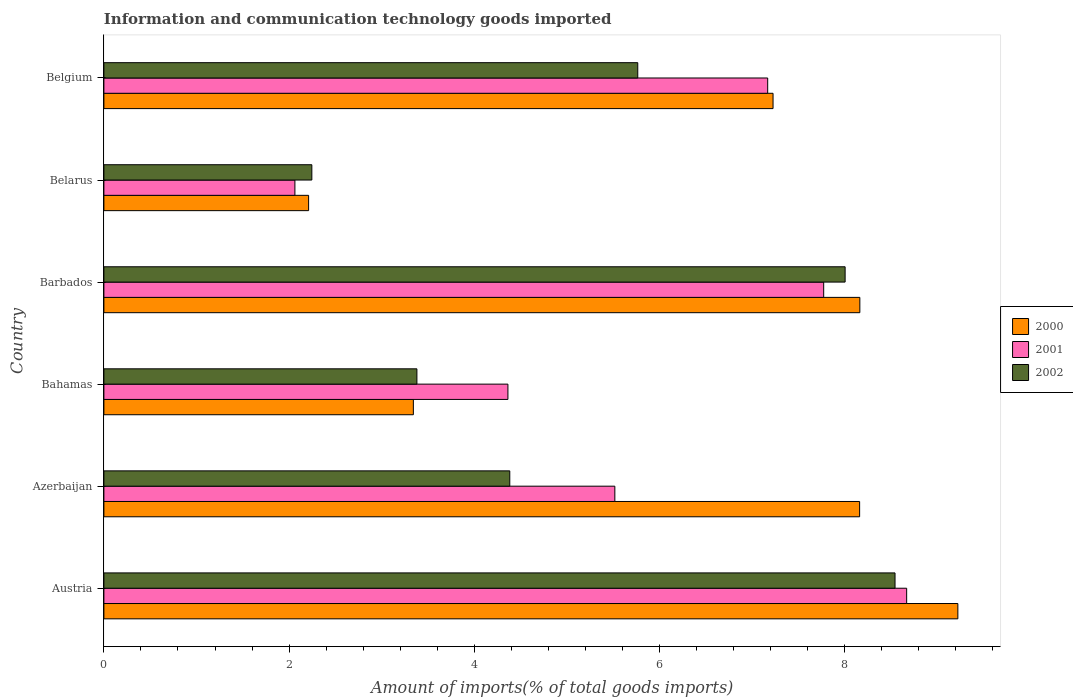How many different coloured bars are there?
Your answer should be compact. 3. How many groups of bars are there?
Your response must be concise. 6. Are the number of bars on each tick of the Y-axis equal?
Make the answer very short. Yes. How many bars are there on the 1st tick from the bottom?
Your answer should be compact. 3. What is the label of the 2nd group of bars from the top?
Your answer should be very brief. Belarus. In how many cases, is the number of bars for a given country not equal to the number of legend labels?
Offer a terse response. 0. What is the amount of goods imported in 2001 in Belarus?
Your response must be concise. 2.06. Across all countries, what is the maximum amount of goods imported in 2000?
Give a very brief answer. 9.22. Across all countries, what is the minimum amount of goods imported in 2000?
Offer a very short reply. 2.21. In which country was the amount of goods imported in 2001 maximum?
Make the answer very short. Austria. In which country was the amount of goods imported in 2001 minimum?
Offer a very short reply. Belarus. What is the total amount of goods imported in 2000 in the graph?
Your answer should be very brief. 38.32. What is the difference between the amount of goods imported in 2000 in Austria and that in Barbados?
Offer a very short reply. 1.06. What is the difference between the amount of goods imported in 2000 in Belarus and the amount of goods imported in 2002 in Austria?
Provide a short and direct response. -6.33. What is the average amount of goods imported in 2002 per country?
Provide a short and direct response. 5.39. What is the difference between the amount of goods imported in 2002 and amount of goods imported in 2001 in Barbados?
Provide a succinct answer. 0.23. What is the ratio of the amount of goods imported in 2000 in Barbados to that in Belgium?
Make the answer very short. 1.13. What is the difference between the highest and the second highest amount of goods imported in 2001?
Your answer should be compact. 0.9. What is the difference between the highest and the lowest amount of goods imported in 2001?
Your answer should be very brief. 6.61. In how many countries, is the amount of goods imported in 2002 greater than the average amount of goods imported in 2002 taken over all countries?
Offer a terse response. 3. Is the sum of the amount of goods imported in 2000 in Austria and Belarus greater than the maximum amount of goods imported in 2001 across all countries?
Give a very brief answer. Yes. What does the 1st bar from the top in Azerbaijan represents?
Offer a terse response. 2002. What does the 2nd bar from the bottom in Belarus represents?
Keep it short and to the point. 2001. Are all the bars in the graph horizontal?
Offer a terse response. Yes. How many countries are there in the graph?
Offer a terse response. 6. What is the difference between two consecutive major ticks on the X-axis?
Provide a short and direct response. 2. Does the graph contain any zero values?
Offer a very short reply. No. Does the graph contain grids?
Offer a very short reply. No. Where does the legend appear in the graph?
Keep it short and to the point. Center right. What is the title of the graph?
Keep it short and to the point. Information and communication technology goods imported. What is the label or title of the X-axis?
Offer a terse response. Amount of imports(% of total goods imports). What is the label or title of the Y-axis?
Your response must be concise. Country. What is the Amount of imports(% of total goods imports) in 2000 in Austria?
Ensure brevity in your answer.  9.22. What is the Amount of imports(% of total goods imports) in 2001 in Austria?
Give a very brief answer. 8.67. What is the Amount of imports(% of total goods imports) in 2002 in Austria?
Give a very brief answer. 8.54. What is the Amount of imports(% of total goods imports) in 2000 in Azerbaijan?
Give a very brief answer. 8.16. What is the Amount of imports(% of total goods imports) in 2001 in Azerbaijan?
Your answer should be compact. 5.52. What is the Amount of imports(% of total goods imports) in 2002 in Azerbaijan?
Your answer should be very brief. 4.38. What is the Amount of imports(% of total goods imports) in 2000 in Bahamas?
Offer a very short reply. 3.34. What is the Amount of imports(% of total goods imports) in 2001 in Bahamas?
Your answer should be very brief. 4.36. What is the Amount of imports(% of total goods imports) of 2002 in Bahamas?
Give a very brief answer. 3.38. What is the Amount of imports(% of total goods imports) in 2000 in Barbados?
Keep it short and to the point. 8.16. What is the Amount of imports(% of total goods imports) of 2001 in Barbados?
Ensure brevity in your answer.  7.77. What is the Amount of imports(% of total goods imports) of 2002 in Barbados?
Keep it short and to the point. 8. What is the Amount of imports(% of total goods imports) of 2000 in Belarus?
Offer a very short reply. 2.21. What is the Amount of imports(% of total goods imports) in 2001 in Belarus?
Keep it short and to the point. 2.06. What is the Amount of imports(% of total goods imports) in 2002 in Belarus?
Make the answer very short. 2.25. What is the Amount of imports(% of total goods imports) of 2000 in Belgium?
Offer a terse response. 7.23. What is the Amount of imports(% of total goods imports) of 2001 in Belgium?
Ensure brevity in your answer.  7.17. What is the Amount of imports(% of total goods imports) of 2002 in Belgium?
Your answer should be very brief. 5.76. Across all countries, what is the maximum Amount of imports(% of total goods imports) of 2000?
Provide a short and direct response. 9.22. Across all countries, what is the maximum Amount of imports(% of total goods imports) of 2001?
Provide a succinct answer. 8.67. Across all countries, what is the maximum Amount of imports(% of total goods imports) in 2002?
Your response must be concise. 8.54. Across all countries, what is the minimum Amount of imports(% of total goods imports) in 2000?
Your response must be concise. 2.21. Across all countries, what is the minimum Amount of imports(% of total goods imports) in 2001?
Offer a terse response. 2.06. Across all countries, what is the minimum Amount of imports(% of total goods imports) in 2002?
Give a very brief answer. 2.25. What is the total Amount of imports(% of total goods imports) of 2000 in the graph?
Make the answer very short. 38.32. What is the total Amount of imports(% of total goods imports) of 2001 in the graph?
Offer a very short reply. 35.55. What is the total Amount of imports(% of total goods imports) of 2002 in the graph?
Offer a terse response. 32.32. What is the difference between the Amount of imports(% of total goods imports) in 2000 in Austria and that in Azerbaijan?
Make the answer very short. 1.06. What is the difference between the Amount of imports(% of total goods imports) of 2001 in Austria and that in Azerbaijan?
Your answer should be compact. 3.15. What is the difference between the Amount of imports(% of total goods imports) of 2002 in Austria and that in Azerbaijan?
Provide a succinct answer. 4.16. What is the difference between the Amount of imports(% of total goods imports) in 2000 in Austria and that in Bahamas?
Ensure brevity in your answer.  5.88. What is the difference between the Amount of imports(% of total goods imports) of 2001 in Austria and that in Bahamas?
Provide a short and direct response. 4.31. What is the difference between the Amount of imports(% of total goods imports) in 2002 in Austria and that in Bahamas?
Offer a terse response. 5.16. What is the difference between the Amount of imports(% of total goods imports) of 2000 in Austria and that in Barbados?
Your answer should be compact. 1.06. What is the difference between the Amount of imports(% of total goods imports) in 2001 in Austria and that in Barbados?
Provide a short and direct response. 0.9. What is the difference between the Amount of imports(% of total goods imports) of 2002 in Austria and that in Barbados?
Keep it short and to the point. 0.54. What is the difference between the Amount of imports(% of total goods imports) of 2000 in Austria and that in Belarus?
Offer a very short reply. 7.01. What is the difference between the Amount of imports(% of total goods imports) in 2001 in Austria and that in Belarus?
Offer a terse response. 6.61. What is the difference between the Amount of imports(% of total goods imports) in 2002 in Austria and that in Belarus?
Provide a succinct answer. 6.3. What is the difference between the Amount of imports(% of total goods imports) in 2000 in Austria and that in Belgium?
Your answer should be very brief. 2. What is the difference between the Amount of imports(% of total goods imports) of 2001 in Austria and that in Belgium?
Provide a short and direct response. 1.5. What is the difference between the Amount of imports(% of total goods imports) in 2002 in Austria and that in Belgium?
Ensure brevity in your answer.  2.78. What is the difference between the Amount of imports(% of total goods imports) of 2000 in Azerbaijan and that in Bahamas?
Your response must be concise. 4.82. What is the difference between the Amount of imports(% of total goods imports) in 2001 in Azerbaijan and that in Bahamas?
Offer a very short reply. 1.15. What is the difference between the Amount of imports(% of total goods imports) in 2002 in Azerbaijan and that in Bahamas?
Make the answer very short. 1. What is the difference between the Amount of imports(% of total goods imports) in 2000 in Azerbaijan and that in Barbados?
Offer a terse response. -0. What is the difference between the Amount of imports(% of total goods imports) of 2001 in Azerbaijan and that in Barbados?
Make the answer very short. -2.26. What is the difference between the Amount of imports(% of total goods imports) in 2002 in Azerbaijan and that in Barbados?
Offer a terse response. -3.62. What is the difference between the Amount of imports(% of total goods imports) of 2000 in Azerbaijan and that in Belarus?
Provide a short and direct response. 5.95. What is the difference between the Amount of imports(% of total goods imports) of 2001 in Azerbaijan and that in Belarus?
Provide a short and direct response. 3.45. What is the difference between the Amount of imports(% of total goods imports) of 2002 in Azerbaijan and that in Belarus?
Your answer should be compact. 2.14. What is the difference between the Amount of imports(% of total goods imports) in 2000 in Azerbaijan and that in Belgium?
Ensure brevity in your answer.  0.93. What is the difference between the Amount of imports(% of total goods imports) of 2001 in Azerbaijan and that in Belgium?
Offer a terse response. -1.65. What is the difference between the Amount of imports(% of total goods imports) of 2002 in Azerbaijan and that in Belgium?
Your answer should be compact. -1.38. What is the difference between the Amount of imports(% of total goods imports) in 2000 in Bahamas and that in Barbados?
Offer a very short reply. -4.82. What is the difference between the Amount of imports(% of total goods imports) in 2001 in Bahamas and that in Barbados?
Your response must be concise. -3.41. What is the difference between the Amount of imports(% of total goods imports) of 2002 in Bahamas and that in Barbados?
Provide a succinct answer. -4.62. What is the difference between the Amount of imports(% of total goods imports) in 2000 in Bahamas and that in Belarus?
Ensure brevity in your answer.  1.13. What is the difference between the Amount of imports(% of total goods imports) in 2001 in Bahamas and that in Belarus?
Make the answer very short. 2.3. What is the difference between the Amount of imports(% of total goods imports) in 2002 in Bahamas and that in Belarus?
Offer a very short reply. 1.13. What is the difference between the Amount of imports(% of total goods imports) in 2000 in Bahamas and that in Belgium?
Keep it short and to the point. -3.88. What is the difference between the Amount of imports(% of total goods imports) in 2001 in Bahamas and that in Belgium?
Provide a short and direct response. -2.81. What is the difference between the Amount of imports(% of total goods imports) of 2002 in Bahamas and that in Belgium?
Your answer should be very brief. -2.38. What is the difference between the Amount of imports(% of total goods imports) in 2000 in Barbados and that in Belarus?
Give a very brief answer. 5.95. What is the difference between the Amount of imports(% of total goods imports) of 2001 in Barbados and that in Belarus?
Your answer should be compact. 5.71. What is the difference between the Amount of imports(% of total goods imports) of 2002 in Barbados and that in Belarus?
Offer a terse response. 5.76. What is the difference between the Amount of imports(% of total goods imports) of 2000 in Barbados and that in Belgium?
Keep it short and to the point. 0.94. What is the difference between the Amount of imports(% of total goods imports) of 2001 in Barbados and that in Belgium?
Your response must be concise. 0.6. What is the difference between the Amount of imports(% of total goods imports) in 2002 in Barbados and that in Belgium?
Keep it short and to the point. 2.24. What is the difference between the Amount of imports(% of total goods imports) of 2000 in Belarus and that in Belgium?
Your answer should be compact. -5.01. What is the difference between the Amount of imports(% of total goods imports) in 2001 in Belarus and that in Belgium?
Give a very brief answer. -5.11. What is the difference between the Amount of imports(% of total goods imports) of 2002 in Belarus and that in Belgium?
Ensure brevity in your answer.  -3.52. What is the difference between the Amount of imports(% of total goods imports) of 2000 in Austria and the Amount of imports(% of total goods imports) of 2001 in Azerbaijan?
Your response must be concise. 3.7. What is the difference between the Amount of imports(% of total goods imports) in 2000 in Austria and the Amount of imports(% of total goods imports) in 2002 in Azerbaijan?
Offer a very short reply. 4.84. What is the difference between the Amount of imports(% of total goods imports) of 2001 in Austria and the Amount of imports(% of total goods imports) of 2002 in Azerbaijan?
Provide a short and direct response. 4.29. What is the difference between the Amount of imports(% of total goods imports) of 2000 in Austria and the Amount of imports(% of total goods imports) of 2001 in Bahamas?
Your answer should be compact. 4.86. What is the difference between the Amount of imports(% of total goods imports) of 2000 in Austria and the Amount of imports(% of total goods imports) of 2002 in Bahamas?
Provide a short and direct response. 5.84. What is the difference between the Amount of imports(% of total goods imports) of 2001 in Austria and the Amount of imports(% of total goods imports) of 2002 in Bahamas?
Your response must be concise. 5.29. What is the difference between the Amount of imports(% of total goods imports) in 2000 in Austria and the Amount of imports(% of total goods imports) in 2001 in Barbados?
Provide a short and direct response. 1.45. What is the difference between the Amount of imports(% of total goods imports) in 2000 in Austria and the Amount of imports(% of total goods imports) in 2002 in Barbados?
Offer a terse response. 1.22. What is the difference between the Amount of imports(% of total goods imports) in 2001 in Austria and the Amount of imports(% of total goods imports) in 2002 in Barbados?
Provide a short and direct response. 0.66. What is the difference between the Amount of imports(% of total goods imports) in 2000 in Austria and the Amount of imports(% of total goods imports) in 2001 in Belarus?
Make the answer very short. 7.16. What is the difference between the Amount of imports(% of total goods imports) in 2000 in Austria and the Amount of imports(% of total goods imports) in 2002 in Belarus?
Make the answer very short. 6.98. What is the difference between the Amount of imports(% of total goods imports) of 2001 in Austria and the Amount of imports(% of total goods imports) of 2002 in Belarus?
Offer a terse response. 6.42. What is the difference between the Amount of imports(% of total goods imports) in 2000 in Austria and the Amount of imports(% of total goods imports) in 2001 in Belgium?
Keep it short and to the point. 2.05. What is the difference between the Amount of imports(% of total goods imports) in 2000 in Austria and the Amount of imports(% of total goods imports) in 2002 in Belgium?
Your response must be concise. 3.46. What is the difference between the Amount of imports(% of total goods imports) in 2001 in Austria and the Amount of imports(% of total goods imports) in 2002 in Belgium?
Keep it short and to the point. 2.9. What is the difference between the Amount of imports(% of total goods imports) of 2000 in Azerbaijan and the Amount of imports(% of total goods imports) of 2001 in Bahamas?
Your response must be concise. 3.8. What is the difference between the Amount of imports(% of total goods imports) of 2000 in Azerbaijan and the Amount of imports(% of total goods imports) of 2002 in Bahamas?
Give a very brief answer. 4.78. What is the difference between the Amount of imports(% of total goods imports) in 2001 in Azerbaijan and the Amount of imports(% of total goods imports) in 2002 in Bahamas?
Your answer should be compact. 2.14. What is the difference between the Amount of imports(% of total goods imports) of 2000 in Azerbaijan and the Amount of imports(% of total goods imports) of 2001 in Barbados?
Make the answer very short. 0.39. What is the difference between the Amount of imports(% of total goods imports) in 2000 in Azerbaijan and the Amount of imports(% of total goods imports) in 2002 in Barbados?
Offer a very short reply. 0.16. What is the difference between the Amount of imports(% of total goods imports) in 2001 in Azerbaijan and the Amount of imports(% of total goods imports) in 2002 in Barbados?
Provide a short and direct response. -2.49. What is the difference between the Amount of imports(% of total goods imports) in 2000 in Azerbaijan and the Amount of imports(% of total goods imports) in 2001 in Belarus?
Ensure brevity in your answer.  6.1. What is the difference between the Amount of imports(% of total goods imports) of 2000 in Azerbaijan and the Amount of imports(% of total goods imports) of 2002 in Belarus?
Offer a very short reply. 5.92. What is the difference between the Amount of imports(% of total goods imports) of 2001 in Azerbaijan and the Amount of imports(% of total goods imports) of 2002 in Belarus?
Give a very brief answer. 3.27. What is the difference between the Amount of imports(% of total goods imports) of 2000 in Azerbaijan and the Amount of imports(% of total goods imports) of 2002 in Belgium?
Provide a succinct answer. 2.4. What is the difference between the Amount of imports(% of total goods imports) in 2001 in Azerbaijan and the Amount of imports(% of total goods imports) in 2002 in Belgium?
Keep it short and to the point. -0.25. What is the difference between the Amount of imports(% of total goods imports) in 2000 in Bahamas and the Amount of imports(% of total goods imports) in 2001 in Barbados?
Offer a terse response. -4.43. What is the difference between the Amount of imports(% of total goods imports) of 2000 in Bahamas and the Amount of imports(% of total goods imports) of 2002 in Barbados?
Ensure brevity in your answer.  -4.66. What is the difference between the Amount of imports(% of total goods imports) of 2001 in Bahamas and the Amount of imports(% of total goods imports) of 2002 in Barbados?
Make the answer very short. -3.64. What is the difference between the Amount of imports(% of total goods imports) in 2000 in Bahamas and the Amount of imports(% of total goods imports) in 2001 in Belarus?
Provide a short and direct response. 1.28. What is the difference between the Amount of imports(% of total goods imports) in 2000 in Bahamas and the Amount of imports(% of total goods imports) in 2002 in Belarus?
Make the answer very short. 1.1. What is the difference between the Amount of imports(% of total goods imports) in 2001 in Bahamas and the Amount of imports(% of total goods imports) in 2002 in Belarus?
Offer a very short reply. 2.12. What is the difference between the Amount of imports(% of total goods imports) of 2000 in Bahamas and the Amount of imports(% of total goods imports) of 2001 in Belgium?
Provide a short and direct response. -3.83. What is the difference between the Amount of imports(% of total goods imports) of 2000 in Bahamas and the Amount of imports(% of total goods imports) of 2002 in Belgium?
Offer a terse response. -2.42. What is the difference between the Amount of imports(% of total goods imports) in 2001 in Bahamas and the Amount of imports(% of total goods imports) in 2002 in Belgium?
Provide a succinct answer. -1.4. What is the difference between the Amount of imports(% of total goods imports) in 2000 in Barbados and the Amount of imports(% of total goods imports) in 2001 in Belarus?
Keep it short and to the point. 6.1. What is the difference between the Amount of imports(% of total goods imports) in 2000 in Barbados and the Amount of imports(% of total goods imports) in 2002 in Belarus?
Offer a terse response. 5.92. What is the difference between the Amount of imports(% of total goods imports) of 2001 in Barbados and the Amount of imports(% of total goods imports) of 2002 in Belarus?
Keep it short and to the point. 5.53. What is the difference between the Amount of imports(% of total goods imports) of 2000 in Barbados and the Amount of imports(% of total goods imports) of 2001 in Belgium?
Keep it short and to the point. 1. What is the difference between the Amount of imports(% of total goods imports) of 2000 in Barbados and the Amount of imports(% of total goods imports) of 2002 in Belgium?
Offer a very short reply. 2.4. What is the difference between the Amount of imports(% of total goods imports) of 2001 in Barbados and the Amount of imports(% of total goods imports) of 2002 in Belgium?
Make the answer very short. 2.01. What is the difference between the Amount of imports(% of total goods imports) in 2000 in Belarus and the Amount of imports(% of total goods imports) in 2001 in Belgium?
Your response must be concise. -4.96. What is the difference between the Amount of imports(% of total goods imports) in 2000 in Belarus and the Amount of imports(% of total goods imports) in 2002 in Belgium?
Your response must be concise. -3.55. What is the difference between the Amount of imports(% of total goods imports) in 2001 in Belarus and the Amount of imports(% of total goods imports) in 2002 in Belgium?
Make the answer very short. -3.7. What is the average Amount of imports(% of total goods imports) in 2000 per country?
Make the answer very short. 6.39. What is the average Amount of imports(% of total goods imports) in 2001 per country?
Your answer should be very brief. 5.93. What is the average Amount of imports(% of total goods imports) in 2002 per country?
Ensure brevity in your answer.  5.39. What is the difference between the Amount of imports(% of total goods imports) in 2000 and Amount of imports(% of total goods imports) in 2001 in Austria?
Provide a short and direct response. 0.55. What is the difference between the Amount of imports(% of total goods imports) in 2000 and Amount of imports(% of total goods imports) in 2002 in Austria?
Keep it short and to the point. 0.68. What is the difference between the Amount of imports(% of total goods imports) of 2001 and Amount of imports(% of total goods imports) of 2002 in Austria?
Give a very brief answer. 0.13. What is the difference between the Amount of imports(% of total goods imports) in 2000 and Amount of imports(% of total goods imports) in 2001 in Azerbaijan?
Ensure brevity in your answer.  2.64. What is the difference between the Amount of imports(% of total goods imports) in 2000 and Amount of imports(% of total goods imports) in 2002 in Azerbaijan?
Make the answer very short. 3.78. What is the difference between the Amount of imports(% of total goods imports) in 2001 and Amount of imports(% of total goods imports) in 2002 in Azerbaijan?
Your response must be concise. 1.13. What is the difference between the Amount of imports(% of total goods imports) of 2000 and Amount of imports(% of total goods imports) of 2001 in Bahamas?
Your response must be concise. -1.02. What is the difference between the Amount of imports(% of total goods imports) of 2000 and Amount of imports(% of total goods imports) of 2002 in Bahamas?
Your answer should be very brief. -0.04. What is the difference between the Amount of imports(% of total goods imports) in 2001 and Amount of imports(% of total goods imports) in 2002 in Bahamas?
Keep it short and to the point. 0.98. What is the difference between the Amount of imports(% of total goods imports) of 2000 and Amount of imports(% of total goods imports) of 2001 in Barbados?
Your response must be concise. 0.39. What is the difference between the Amount of imports(% of total goods imports) of 2000 and Amount of imports(% of total goods imports) of 2002 in Barbados?
Give a very brief answer. 0.16. What is the difference between the Amount of imports(% of total goods imports) of 2001 and Amount of imports(% of total goods imports) of 2002 in Barbados?
Offer a very short reply. -0.23. What is the difference between the Amount of imports(% of total goods imports) in 2000 and Amount of imports(% of total goods imports) in 2001 in Belarus?
Keep it short and to the point. 0.15. What is the difference between the Amount of imports(% of total goods imports) of 2000 and Amount of imports(% of total goods imports) of 2002 in Belarus?
Offer a terse response. -0.03. What is the difference between the Amount of imports(% of total goods imports) in 2001 and Amount of imports(% of total goods imports) in 2002 in Belarus?
Provide a succinct answer. -0.18. What is the difference between the Amount of imports(% of total goods imports) in 2000 and Amount of imports(% of total goods imports) in 2001 in Belgium?
Your answer should be very brief. 0.06. What is the difference between the Amount of imports(% of total goods imports) in 2000 and Amount of imports(% of total goods imports) in 2002 in Belgium?
Offer a terse response. 1.46. What is the difference between the Amount of imports(% of total goods imports) of 2001 and Amount of imports(% of total goods imports) of 2002 in Belgium?
Your answer should be very brief. 1.4. What is the ratio of the Amount of imports(% of total goods imports) of 2000 in Austria to that in Azerbaijan?
Ensure brevity in your answer.  1.13. What is the ratio of the Amount of imports(% of total goods imports) in 2001 in Austria to that in Azerbaijan?
Provide a succinct answer. 1.57. What is the ratio of the Amount of imports(% of total goods imports) in 2002 in Austria to that in Azerbaijan?
Keep it short and to the point. 1.95. What is the ratio of the Amount of imports(% of total goods imports) in 2000 in Austria to that in Bahamas?
Make the answer very short. 2.76. What is the ratio of the Amount of imports(% of total goods imports) in 2001 in Austria to that in Bahamas?
Your response must be concise. 1.99. What is the ratio of the Amount of imports(% of total goods imports) in 2002 in Austria to that in Bahamas?
Provide a succinct answer. 2.53. What is the ratio of the Amount of imports(% of total goods imports) in 2000 in Austria to that in Barbados?
Provide a succinct answer. 1.13. What is the ratio of the Amount of imports(% of total goods imports) in 2001 in Austria to that in Barbados?
Your answer should be very brief. 1.12. What is the ratio of the Amount of imports(% of total goods imports) in 2002 in Austria to that in Barbados?
Offer a very short reply. 1.07. What is the ratio of the Amount of imports(% of total goods imports) in 2000 in Austria to that in Belarus?
Ensure brevity in your answer.  4.17. What is the ratio of the Amount of imports(% of total goods imports) of 2001 in Austria to that in Belarus?
Make the answer very short. 4.2. What is the ratio of the Amount of imports(% of total goods imports) in 2002 in Austria to that in Belarus?
Your answer should be compact. 3.8. What is the ratio of the Amount of imports(% of total goods imports) in 2000 in Austria to that in Belgium?
Offer a very short reply. 1.28. What is the ratio of the Amount of imports(% of total goods imports) of 2001 in Austria to that in Belgium?
Your answer should be very brief. 1.21. What is the ratio of the Amount of imports(% of total goods imports) in 2002 in Austria to that in Belgium?
Make the answer very short. 1.48. What is the ratio of the Amount of imports(% of total goods imports) of 2000 in Azerbaijan to that in Bahamas?
Give a very brief answer. 2.44. What is the ratio of the Amount of imports(% of total goods imports) in 2001 in Azerbaijan to that in Bahamas?
Offer a very short reply. 1.26. What is the ratio of the Amount of imports(% of total goods imports) in 2002 in Azerbaijan to that in Bahamas?
Keep it short and to the point. 1.3. What is the ratio of the Amount of imports(% of total goods imports) in 2001 in Azerbaijan to that in Barbados?
Offer a terse response. 0.71. What is the ratio of the Amount of imports(% of total goods imports) in 2002 in Azerbaijan to that in Barbados?
Provide a short and direct response. 0.55. What is the ratio of the Amount of imports(% of total goods imports) in 2000 in Azerbaijan to that in Belarus?
Keep it short and to the point. 3.69. What is the ratio of the Amount of imports(% of total goods imports) in 2001 in Azerbaijan to that in Belarus?
Keep it short and to the point. 2.67. What is the ratio of the Amount of imports(% of total goods imports) of 2002 in Azerbaijan to that in Belarus?
Keep it short and to the point. 1.95. What is the ratio of the Amount of imports(% of total goods imports) in 2000 in Azerbaijan to that in Belgium?
Keep it short and to the point. 1.13. What is the ratio of the Amount of imports(% of total goods imports) in 2001 in Azerbaijan to that in Belgium?
Your answer should be compact. 0.77. What is the ratio of the Amount of imports(% of total goods imports) of 2002 in Azerbaijan to that in Belgium?
Offer a very short reply. 0.76. What is the ratio of the Amount of imports(% of total goods imports) of 2000 in Bahamas to that in Barbados?
Ensure brevity in your answer.  0.41. What is the ratio of the Amount of imports(% of total goods imports) in 2001 in Bahamas to that in Barbados?
Provide a short and direct response. 0.56. What is the ratio of the Amount of imports(% of total goods imports) of 2002 in Bahamas to that in Barbados?
Make the answer very short. 0.42. What is the ratio of the Amount of imports(% of total goods imports) of 2000 in Bahamas to that in Belarus?
Your answer should be compact. 1.51. What is the ratio of the Amount of imports(% of total goods imports) of 2001 in Bahamas to that in Belarus?
Make the answer very short. 2.12. What is the ratio of the Amount of imports(% of total goods imports) of 2002 in Bahamas to that in Belarus?
Your answer should be compact. 1.51. What is the ratio of the Amount of imports(% of total goods imports) of 2000 in Bahamas to that in Belgium?
Provide a short and direct response. 0.46. What is the ratio of the Amount of imports(% of total goods imports) in 2001 in Bahamas to that in Belgium?
Keep it short and to the point. 0.61. What is the ratio of the Amount of imports(% of total goods imports) in 2002 in Bahamas to that in Belgium?
Give a very brief answer. 0.59. What is the ratio of the Amount of imports(% of total goods imports) of 2000 in Barbados to that in Belarus?
Your response must be concise. 3.69. What is the ratio of the Amount of imports(% of total goods imports) of 2001 in Barbados to that in Belarus?
Offer a very short reply. 3.77. What is the ratio of the Amount of imports(% of total goods imports) in 2002 in Barbados to that in Belarus?
Make the answer very short. 3.56. What is the ratio of the Amount of imports(% of total goods imports) of 2000 in Barbados to that in Belgium?
Offer a very short reply. 1.13. What is the ratio of the Amount of imports(% of total goods imports) in 2001 in Barbados to that in Belgium?
Provide a succinct answer. 1.08. What is the ratio of the Amount of imports(% of total goods imports) of 2002 in Barbados to that in Belgium?
Offer a very short reply. 1.39. What is the ratio of the Amount of imports(% of total goods imports) in 2000 in Belarus to that in Belgium?
Make the answer very short. 0.31. What is the ratio of the Amount of imports(% of total goods imports) in 2001 in Belarus to that in Belgium?
Your answer should be compact. 0.29. What is the ratio of the Amount of imports(% of total goods imports) of 2002 in Belarus to that in Belgium?
Give a very brief answer. 0.39. What is the difference between the highest and the second highest Amount of imports(% of total goods imports) of 2000?
Provide a succinct answer. 1.06. What is the difference between the highest and the second highest Amount of imports(% of total goods imports) of 2001?
Your answer should be very brief. 0.9. What is the difference between the highest and the second highest Amount of imports(% of total goods imports) of 2002?
Give a very brief answer. 0.54. What is the difference between the highest and the lowest Amount of imports(% of total goods imports) in 2000?
Provide a succinct answer. 7.01. What is the difference between the highest and the lowest Amount of imports(% of total goods imports) in 2001?
Your answer should be very brief. 6.61. What is the difference between the highest and the lowest Amount of imports(% of total goods imports) of 2002?
Give a very brief answer. 6.3. 